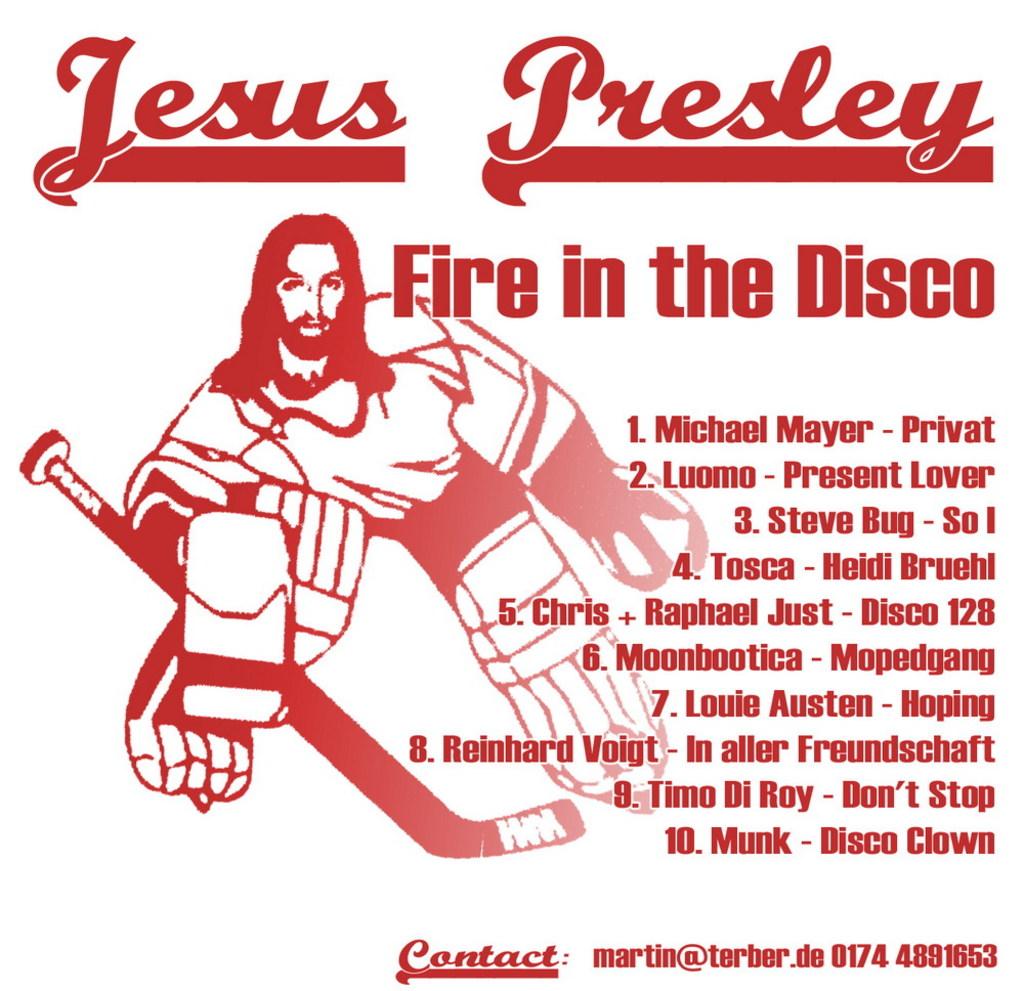What is the name on the top left?
Ensure brevity in your answer.  Jesus. 